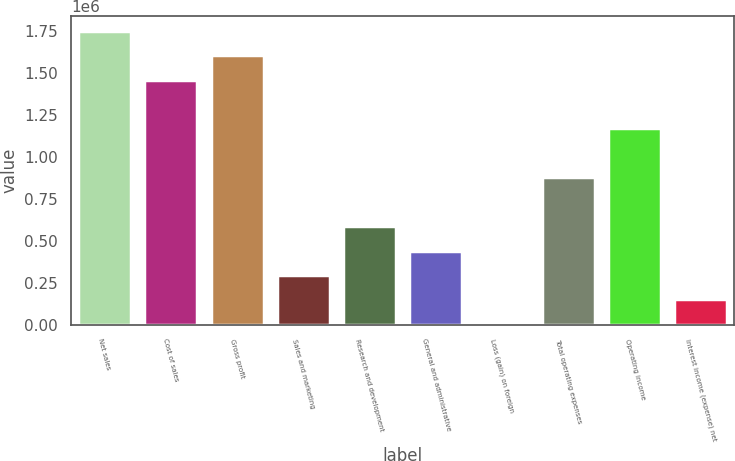<chart> <loc_0><loc_0><loc_500><loc_500><bar_chart><fcel>Net sales<fcel>Cost of sales<fcel>Gross profit<fcel>Sales and marketing<fcel>Research and development<fcel>General and administrative<fcel>Loss (gain) on foreign<fcel>Total operating expenses<fcel>Operating income<fcel>Interest income (expense) net<nl><fcel>1.75062e+06<fcel>1.45987e+06<fcel>1.60525e+06<fcel>296895<fcel>587640<fcel>442267<fcel>6150<fcel>878384<fcel>1.16913e+06<fcel>151522<nl></chart> 